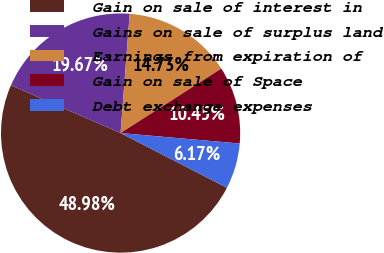<chart> <loc_0><loc_0><loc_500><loc_500><pie_chart><fcel>Gain on sale of interest in<fcel>Gains on sale of surplus land<fcel>Earnings from expiration of<fcel>Gain on sale of Space<fcel>Debt exchange expenses<nl><fcel>48.98%<fcel>19.67%<fcel>14.73%<fcel>10.45%<fcel>6.17%<nl></chart> 